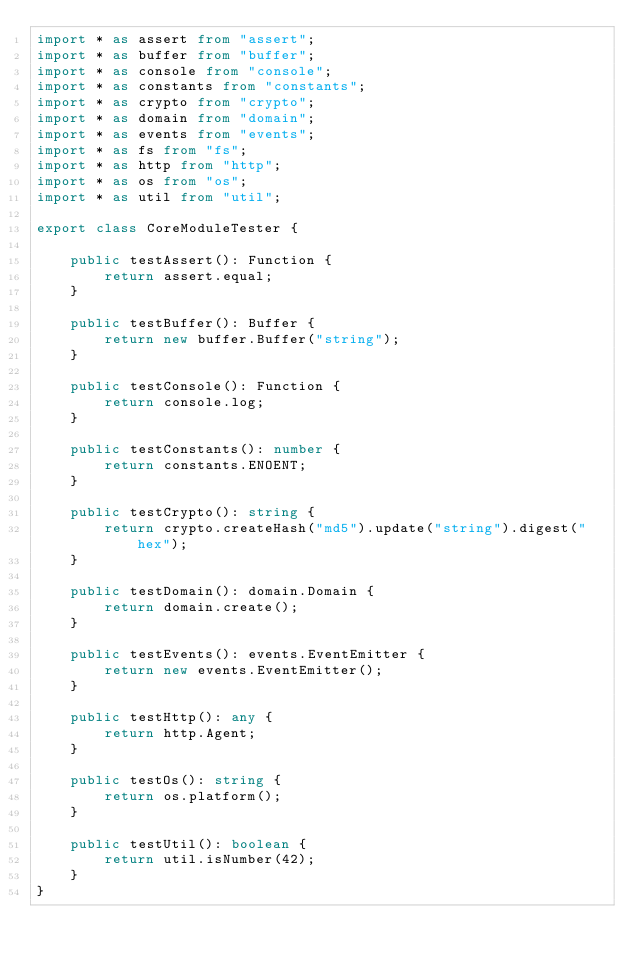Convert code to text. <code><loc_0><loc_0><loc_500><loc_500><_TypeScript_>import * as assert from "assert";
import * as buffer from "buffer";
import * as console from "console";
import * as constants from "constants";
import * as crypto from "crypto";
import * as domain from "domain";
import * as events from "events";
import * as fs from "fs";
import * as http from "http";
import * as os from "os";
import * as util from "util";

export class CoreModuleTester {

    public testAssert(): Function {
        return assert.equal;
    }

    public testBuffer(): Buffer {
        return new buffer.Buffer("string");
    }

    public testConsole(): Function {
        return console.log;
    }

    public testConstants(): number {
        return constants.ENOENT;
    }

    public testCrypto(): string {
        return crypto.createHash("md5").update("string").digest("hex");
    }

    public testDomain(): domain.Domain {
        return domain.create();
    }

    public testEvents(): events.EventEmitter {
        return new events.EventEmitter();
    }

    public testHttp(): any {
        return http.Agent;
    }

    public testOs(): string {
        return os.platform();
    }

    public testUtil(): boolean {
        return util.isNumber(42);
    }
}
</code> 